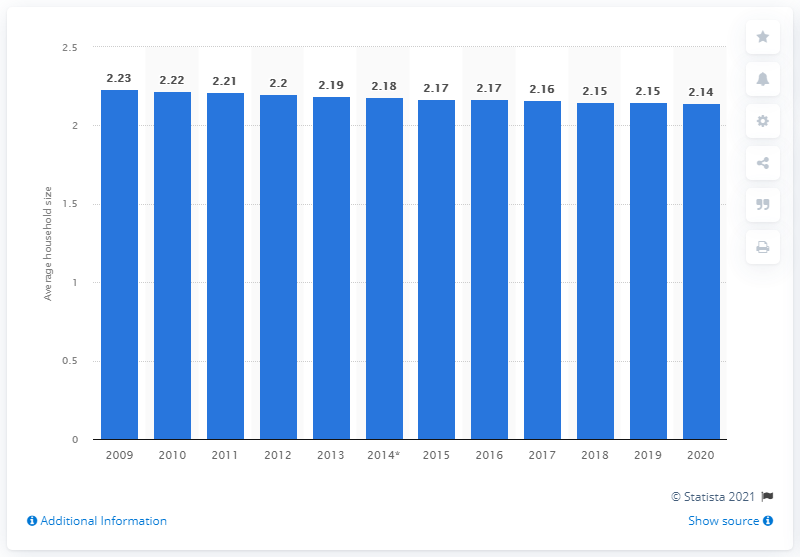Give some essential details in this illustration. In the Netherlands, the average household size was 2.14 people between 2009 and 2020. 